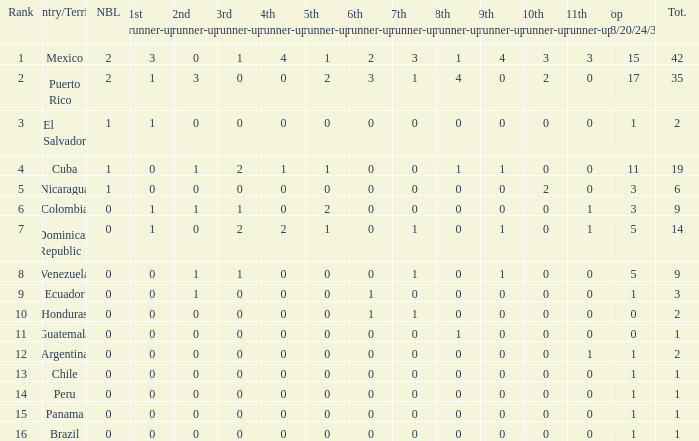What is the total number of 3rd runners-up of the country ranked lower than 12 with a 10th runner-up of 0, an 8th runner-up less than 1, and a 7th runner-up of 0? 4.0. 